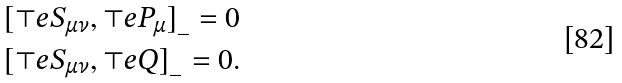<formula> <loc_0><loc_0><loc_500><loc_500>& [ \top e { S } _ { \mu \nu } , \top e { P } _ { \mu } ] _ { \_ } = 0 \\ & [ \top e { S } _ { \mu \nu } , \top e { Q } ] _ { \_ } = 0 .</formula> 